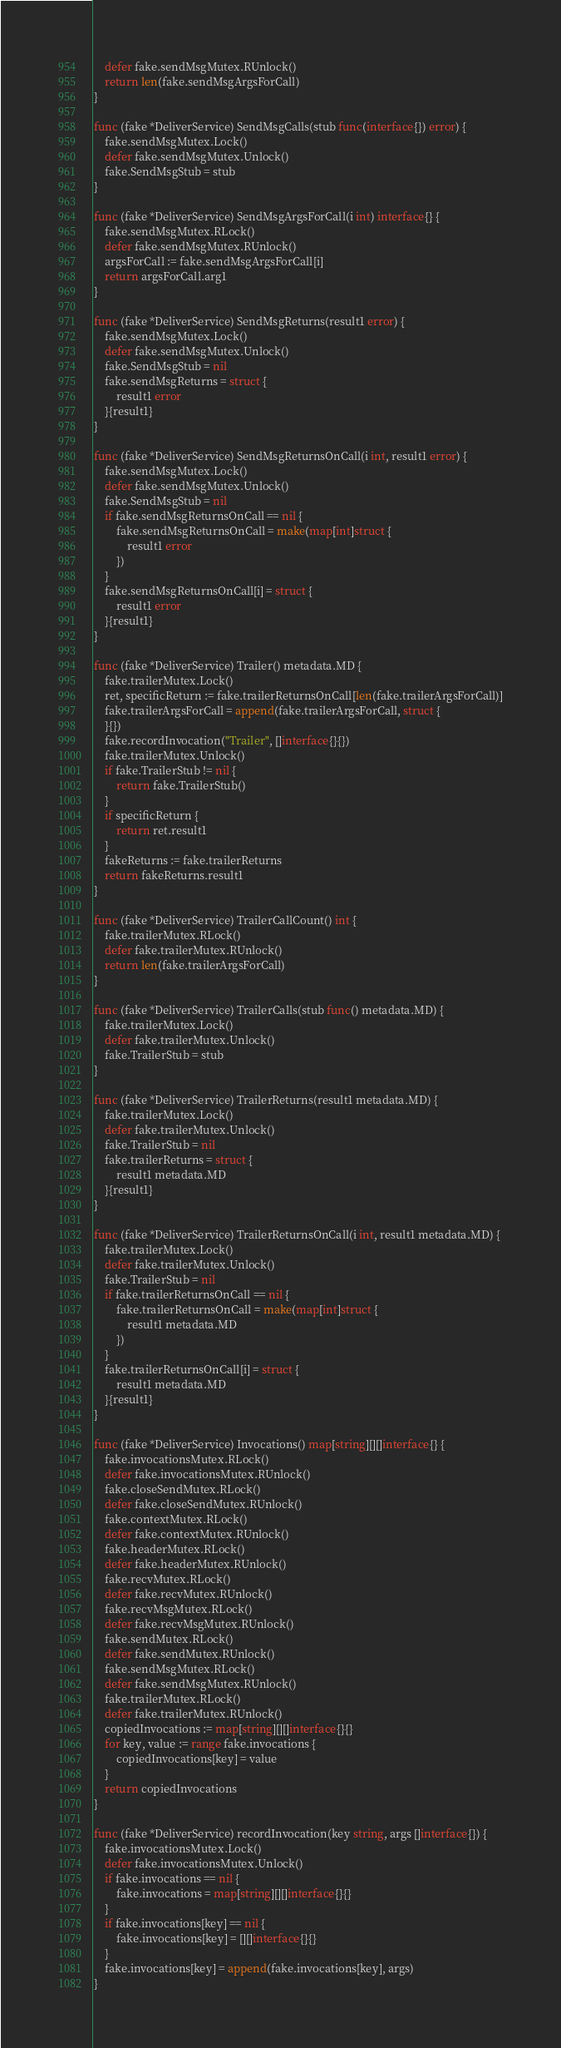Convert code to text. <code><loc_0><loc_0><loc_500><loc_500><_Go_>	defer fake.sendMsgMutex.RUnlock()
	return len(fake.sendMsgArgsForCall)
}

func (fake *DeliverService) SendMsgCalls(stub func(interface{}) error) {
	fake.sendMsgMutex.Lock()
	defer fake.sendMsgMutex.Unlock()
	fake.SendMsgStub = stub
}

func (fake *DeliverService) SendMsgArgsForCall(i int) interface{} {
	fake.sendMsgMutex.RLock()
	defer fake.sendMsgMutex.RUnlock()
	argsForCall := fake.sendMsgArgsForCall[i]
	return argsForCall.arg1
}

func (fake *DeliverService) SendMsgReturns(result1 error) {
	fake.sendMsgMutex.Lock()
	defer fake.sendMsgMutex.Unlock()
	fake.SendMsgStub = nil
	fake.sendMsgReturns = struct {
		result1 error
	}{result1}
}

func (fake *DeliverService) SendMsgReturnsOnCall(i int, result1 error) {
	fake.sendMsgMutex.Lock()
	defer fake.sendMsgMutex.Unlock()
	fake.SendMsgStub = nil
	if fake.sendMsgReturnsOnCall == nil {
		fake.sendMsgReturnsOnCall = make(map[int]struct {
			result1 error
		})
	}
	fake.sendMsgReturnsOnCall[i] = struct {
		result1 error
	}{result1}
}

func (fake *DeliverService) Trailer() metadata.MD {
	fake.trailerMutex.Lock()
	ret, specificReturn := fake.trailerReturnsOnCall[len(fake.trailerArgsForCall)]
	fake.trailerArgsForCall = append(fake.trailerArgsForCall, struct {
	}{})
	fake.recordInvocation("Trailer", []interface{}{})
	fake.trailerMutex.Unlock()
	if fake.TrailerStub != nil {
		return fake.TrailerStub()
	}
	if specificReturn {
		return ret.result1
	}
	fakeReturns := fake.trailerReturns
	return fakeReturns.result1
}

func (fake *DeliverService) TrailerCallCount() int {
	fake.trailerMutex.RLock()
	defer fake.trailerMutex.RUnlock()
	return len(fake.trailerArgsForCall)
}

func (fake *DeliverService) TrailerCalls(stub func() metadata.MD) {
	fake.trailerMutex.Lock()
	defer fake.trailerMutex.Unlock()
	fake.TrailerStub = stub
}

func (fake *DeliverService) TrailerReturns(result1 metadata.MD) {
	fake.trailerMutex.Lock()
	defer fake.trailerMutex.Unlock()
	fake.TrailerStub = nil
	fake.trailerReturns = struct {
		result1 metadata.MD
	}{result1}
}

func (fake *DeliverService) TrailerReturnsOnCall(i int, result1 metadata.MD) {
	fake.trailerMutex.Lock()
	defer fake.trailerMutex.Unlock()
	fake.TrailerStub = nil
	if fake.trailerReturnsOnCall == nil {
		fake.trailerReturnsOnCall = make(map[int]struct {
			result1 metadata.MD
		})
	}
	fake.trailerReturnsOnCall[i] = struct {
		result1 metadata.MD
	}{result1}
}

func (fake *DeliverService) Invocations() map[string][][]interface{} {
	fake.invocationsMutex.RLock()
	defer fake.invocationsMutex.RUnlock()
	fake.closeSendMutex.RLock()
	defer fake.closeSendMutex.RUnlock()
	fake.contextMutex.RLock()
	defer fake.contextMutex.RUnlock()
	fake.headerMutex.RLock()
	defer fake.headerMutex.RUnlock()
	fake.recvMutex.RLock()
	defer fake.recvMutex.RUnlock()
	fake.recvMsgMutex.RLock()
	defer fake.recvMsgMutex.RUnlock()
	fake.sendMutex.RLock()
	defer fake.sendMutex.RUnlock()
	fake.sendMsgMutex.RLock()
	defer fake.sendMsgMutex.RUnlock()
	fake.trailerMutex.RLock()
	defer fake.trailerMutex.RUnlock()
	copiedInvocations := map[string][][]interface{}{}
	for key, value := range fake.invocations {
		copiedInvocations[key] = value
	}
	return copiedInvocations
}

func (fake *DeliverService) recordInvocation(key string, args []interface{}) {
	fake.invocationsMutex.Lock()
	defer fake.invocationsMutex.Unlock()
	if fake.invocations == nil {
		fake.invocations = map[string][][]interface{}{}
	}
	if fake.invocations[key] == nil {
		fake.invocations[key] = [][]interface{}{}
	}
	fake.invocations[key] = append(fake.invocations[key], args)
}
</code> 